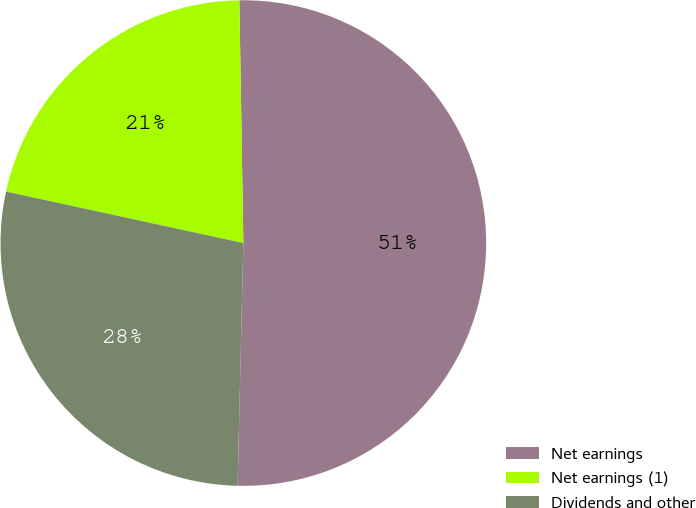Convert chart. <chart><loc_0><loc_0><loc_500><loc_500><pie_chart><fcel>Net earnings<fcel>Net earnings (1)<fcel>Dividends and other<nl><fcel>50.64%<fcel>21.34%<fcel>28.02%<nl></chart> 